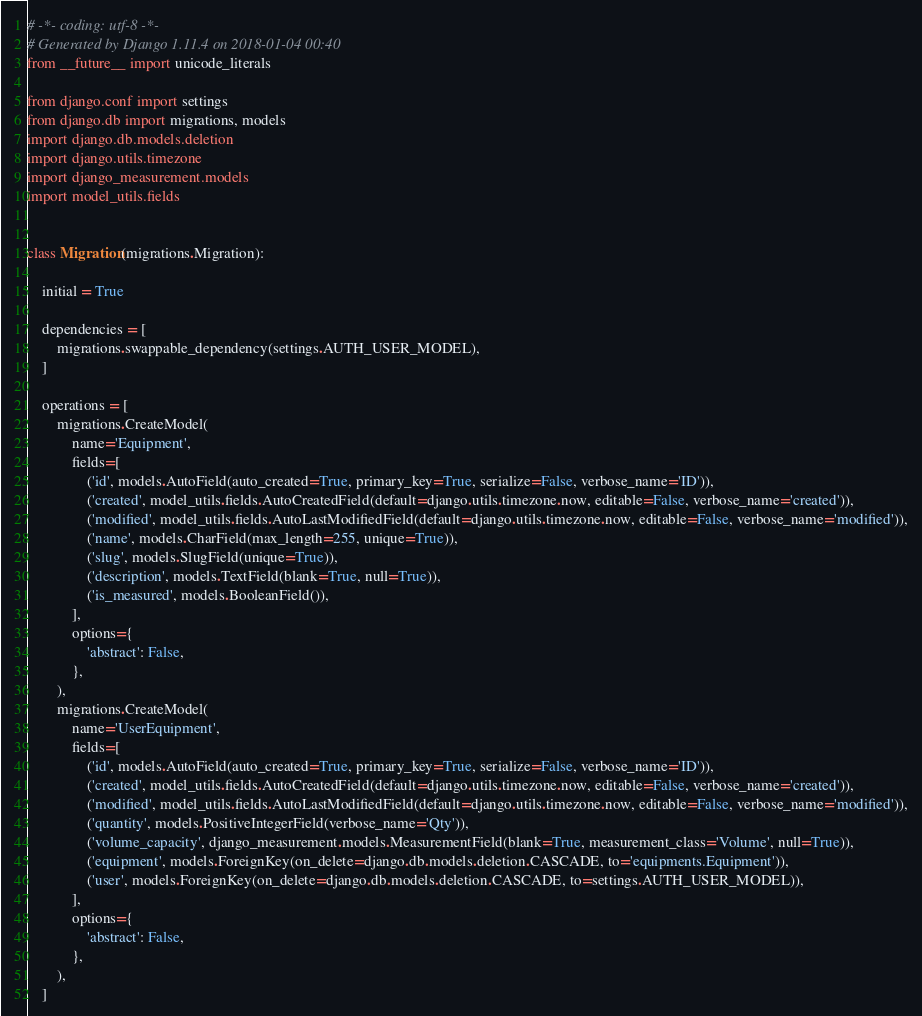<code> <loc_0><loc_0><loc_500><loc_500><_Python_># -*- coding: utf-8 -*-
# Generated by Django 1.11.4 on 2018-01-04 00:40
from __future__ import unicode_literals

from django.conf import settings
from django.db import migrations, models
import django.db.models.deletion
import django.utils.timezone
import django_measurement.models
import model_utils.fields


class Migration(migrations.Migration):

    initial = True

    dependencies = [
        migrations.swappable_dependency(settings.AUTH_USER_MODEL),
    ]

    operations = [
        migrations.CreateModel(
            name='Equipment',
            fields=[
                ('id', models.AutoField(auto_created=True, primary_key=True, serialize=False, verbose_name='ID')),
                ('created', model_utils.fields.AutoCreatedField(default=django.utils.timezone.now, editable=False, verbose_name='created')),
                ('modified', model_utils.fields.AutoLastModifiedField(default=django.utils.timezone.now, editable=False, verbose_name='modified')),
                ('name', models.CharField(max_length=255, unique=True)),
                ('slug', models.SlugField(unique=True)),
                ('description', models.TextField(blank=True, null=True)),
                ('is_measured', models.BooleanField()),
            ],
            options={
                'abstract': False,
            },
        ),
        migrations.CreateModel(
            name='UserEquipment',
            fields=[
                ('id', models.AutoField(auto_created=True, primary_key=True, serialize=False, verbose_name='ID')),
                ('created', model_utils.fields.AutoCreatedField(default=django.utils.timezone.now, editable=False, verbose_name='created')),
                ('modified', model_utils.fields.AutoLastModifiedField(default=django.utils.timezone.now, editable=False, verbose_name='modified')),
                ('quantity', models.PositiveIntegerField(verbose_name='Qty')),
                ('volume_capacity', django_measurement.models.MeasurementField(blank=True, measurement_class='Volume', null=True)),
                ('equipment', models.ForeignKey(on_delete=django.db.models.deletion.CASCADE, to='equipments.Equipment')),
                ('user', models.ForeignKey(on_delete=django.db.models.deletion.CASCADE, to=settings.AUTH_USER_MODEL)),
            ],
            options={
                'abstract': False,
            },
        ),
    ]
</code> 